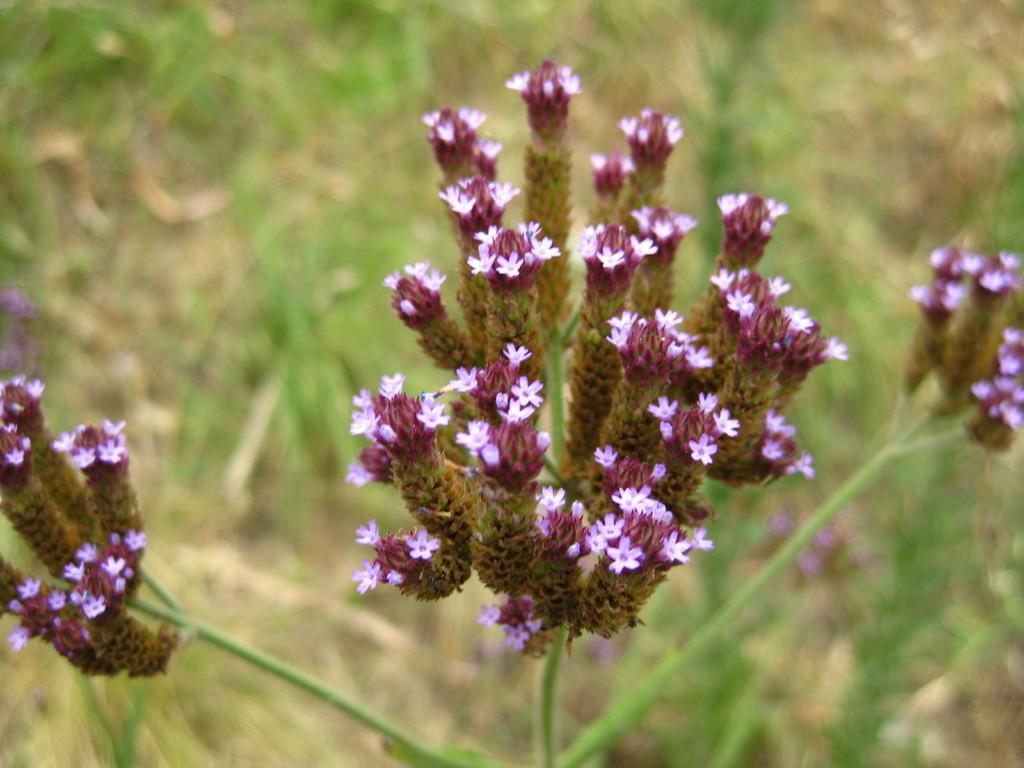What type of objects are present in the image? There are flowers in the image. Where are the flowers located in the image? The flowers are in the front of the image. What can be observed about the background of the image? The background of the image is blurry. What type of activity is the calculator performing in the image? There is no calculator present in the image, so it cannot be performing any activity. 